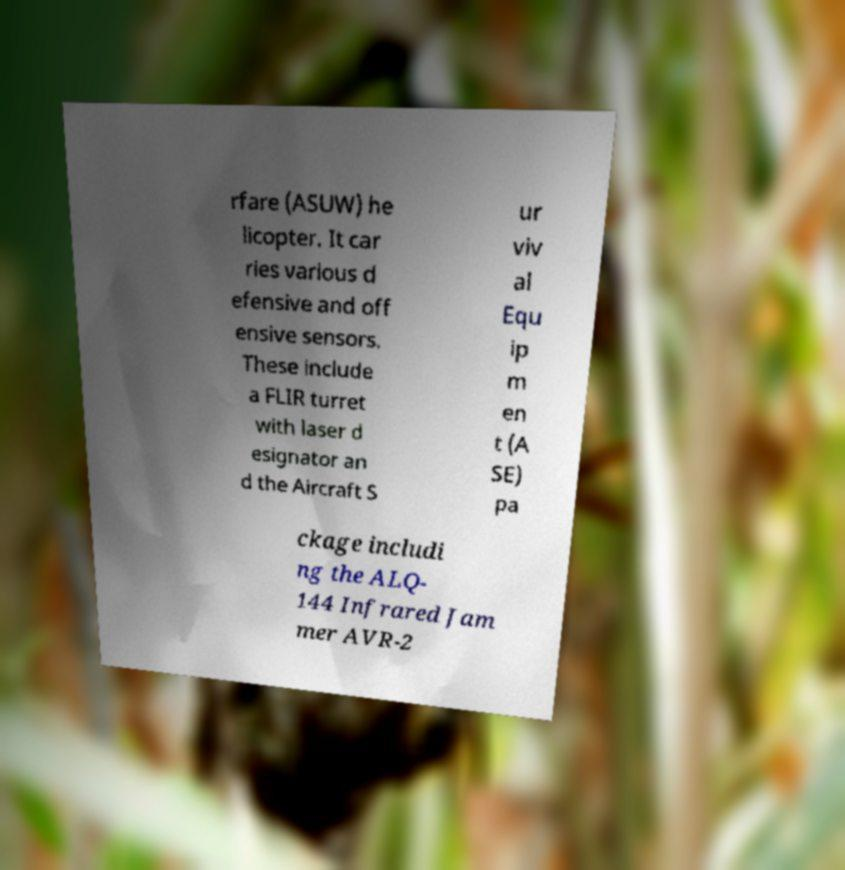I need the written content from this picture converted into text. Can you do that? rfare (ASUW) he licopter. It car ries various d efensive and off ensive sensors. These include a FLIR turret with laser d esignator an d the Aircraft S ur viv al Equ ip m en t (A SE) pa ckage includi ng the ALQ- 144 Infrared Jam mer AVR-2 